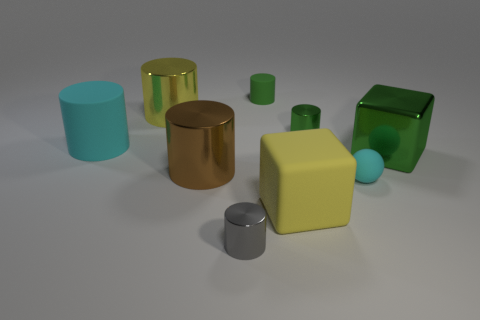Subtract all cyan cylinders. How many cylinders are left? 5 Subtract all green cylinders. How many cylinders are left? 4 Add 1 brown shiny things. How many objects exist? 10 Subtract all blue cylinders. Subtract all purple cubes. How many cylinders are left? 6 Subtract all blocks. How many objects are left? 7 Subtract 1 cyan cylinders. How many objects are left? 8 Subtract all big green rubber spheres. Subtract all big yellow metal cylinders. How many objects are left? 8 Add 9 tiny cyan balls. How many tiny cyan balls are left? 10 Add 3 small purple objects. How many small purple objects exist? 3 